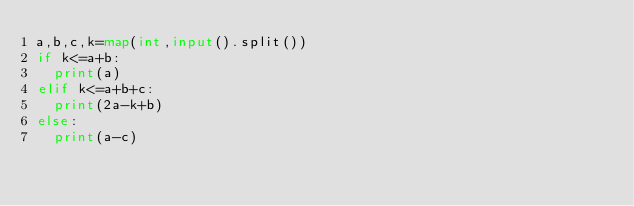Convert code to text. <code><loc_0><loc_0><loc_500><loc_500><_Python_>a,b,c,k=map(int,input().split())
if k<=a+b:
  print(a)
elif k<=a+b+c:
  print(2a-k+b)
else:
  print(a-c)</code> 